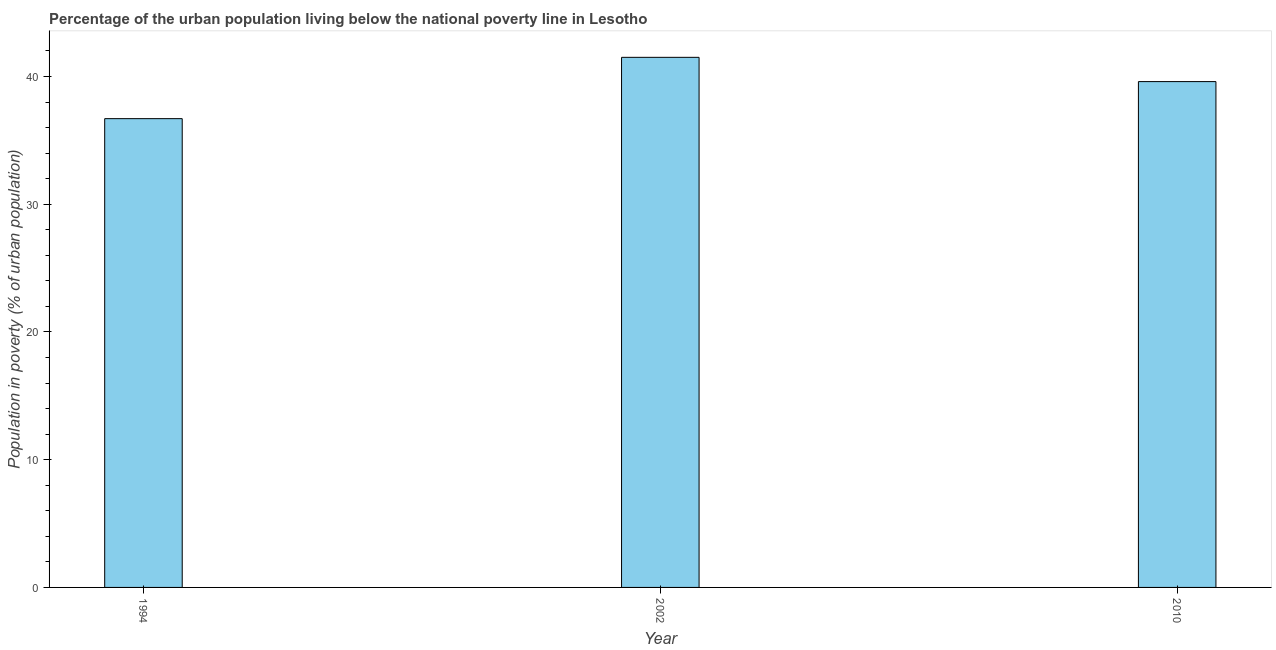Does the graph contain grids?
Keep it short and to the point. No. What is the title of the graph?
Offer a very short reply. Percentage of the urban population living below the national poverty line in Lesotho. What is the label or title of the X-axis?
Provide a succinct answer. Year. What is the label or title of the Y-axis?
Ensure brevity in your answer.  Population in poverty (% of urban population). What is the percentage of urban population living below poverty line in 2010?
Give a very brief answer. 39.6. Across all years, what is the maximum percentage of urban population living below poverty line?
Provide a succinct answer. 41.5. Across all years, what is the minimum percentage of urban population living below poverty line?
Keep it short and to the point. 36.7. In which year was the percentage of urban population living below poverty line maximum?
Your answer should be compact. 2002. What is the sum of the percentage of urban population living below poverty line?
Keep it short and to the point. 117.8. What is the average percentage of urban population living below poverty line per year?
Provide a short and direct response. 39.27. What is the median percentage of urban population living below poverty line?
Provide a succinct answer. 39.6. What is the ratio of the percentage of urban population living below poverty line in 2002 to that in 2010?
Offer a terse response. 1.05. Is the difference between the percentage of urban population living below poverty line in 1994 and 2002 greater than the difference between any two years?
Offer a very short reply. Yes. What is the difference between the highest and the second highest percentage of urban population living below poverty line?
Your answer should be compact. 1.9. Is the sum of the percentage of urban population living below poverty line in 1994 and 2010 greater than the maximum percentage of urban population living below poverty line across all years?
Offer a very short reply. Yes. What is the difference between the highest and the lowest percentage of urban population living below poverty line?
Ensure brevity in your answer.  4.8. In how many years, is the percentage of urban population living below poverty line greater than the average percentage of urban population living below poverty line taken over all years?
Offer a terse response. 2. What is the Population in poverty (% of urban population) of 1994?
Your response must be concise. 36.7. What is the Population in poverty (% of urban population) in 2002?
Your answer should be very brief. 41.5. What is the Population in poverty (% of urban population) of 2010?
Keep it short and to the point. 39.6. What is the difference between the Population in poverty (% of urban population) in 1994 and 2002?
Offer a very short reply. -4.8. What is the difference between the Population in poverty (% of urban population) in 2002 and 2010?
Your answer should be very brief. 1.9. What is the ratio of the Population in poverty (% of urban population) in 1994 to that in 2002?
Provide a short and direct response. 0.88. What is the ratio of the Population in poverty (% of urban population) in 1994 to that in 2010?
Your response must be concise. 0.93. What is the ratio of the Population in poverty (% of urban population) in 2002 to that in 2010?
Your answer should be very brief. 1.05. 